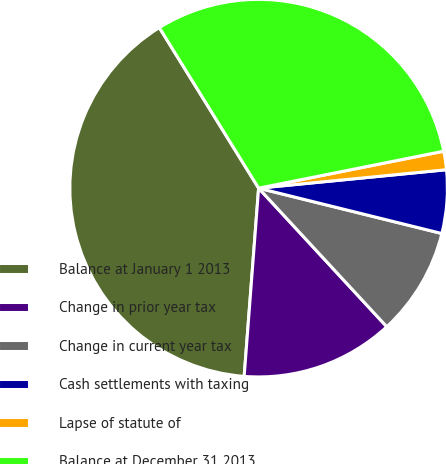Convert chart to OTSL. <chart><loc_0><loc_0><loc_500><loc_500><pie_chart><fcel>Balance at January 1 2013<fcel>Change in prior year tax<fcel>Change in current year tax<fcel>Cash settlements with taxing<fcel>Lapse of statute of<fcel>Balance at December 31 2013<nl><fcel>39.97%<fcel>13.1%<fcel>9.26%<fcel>5.42%<fcel>1.58%<fcel>30.68%<nl></chart> 